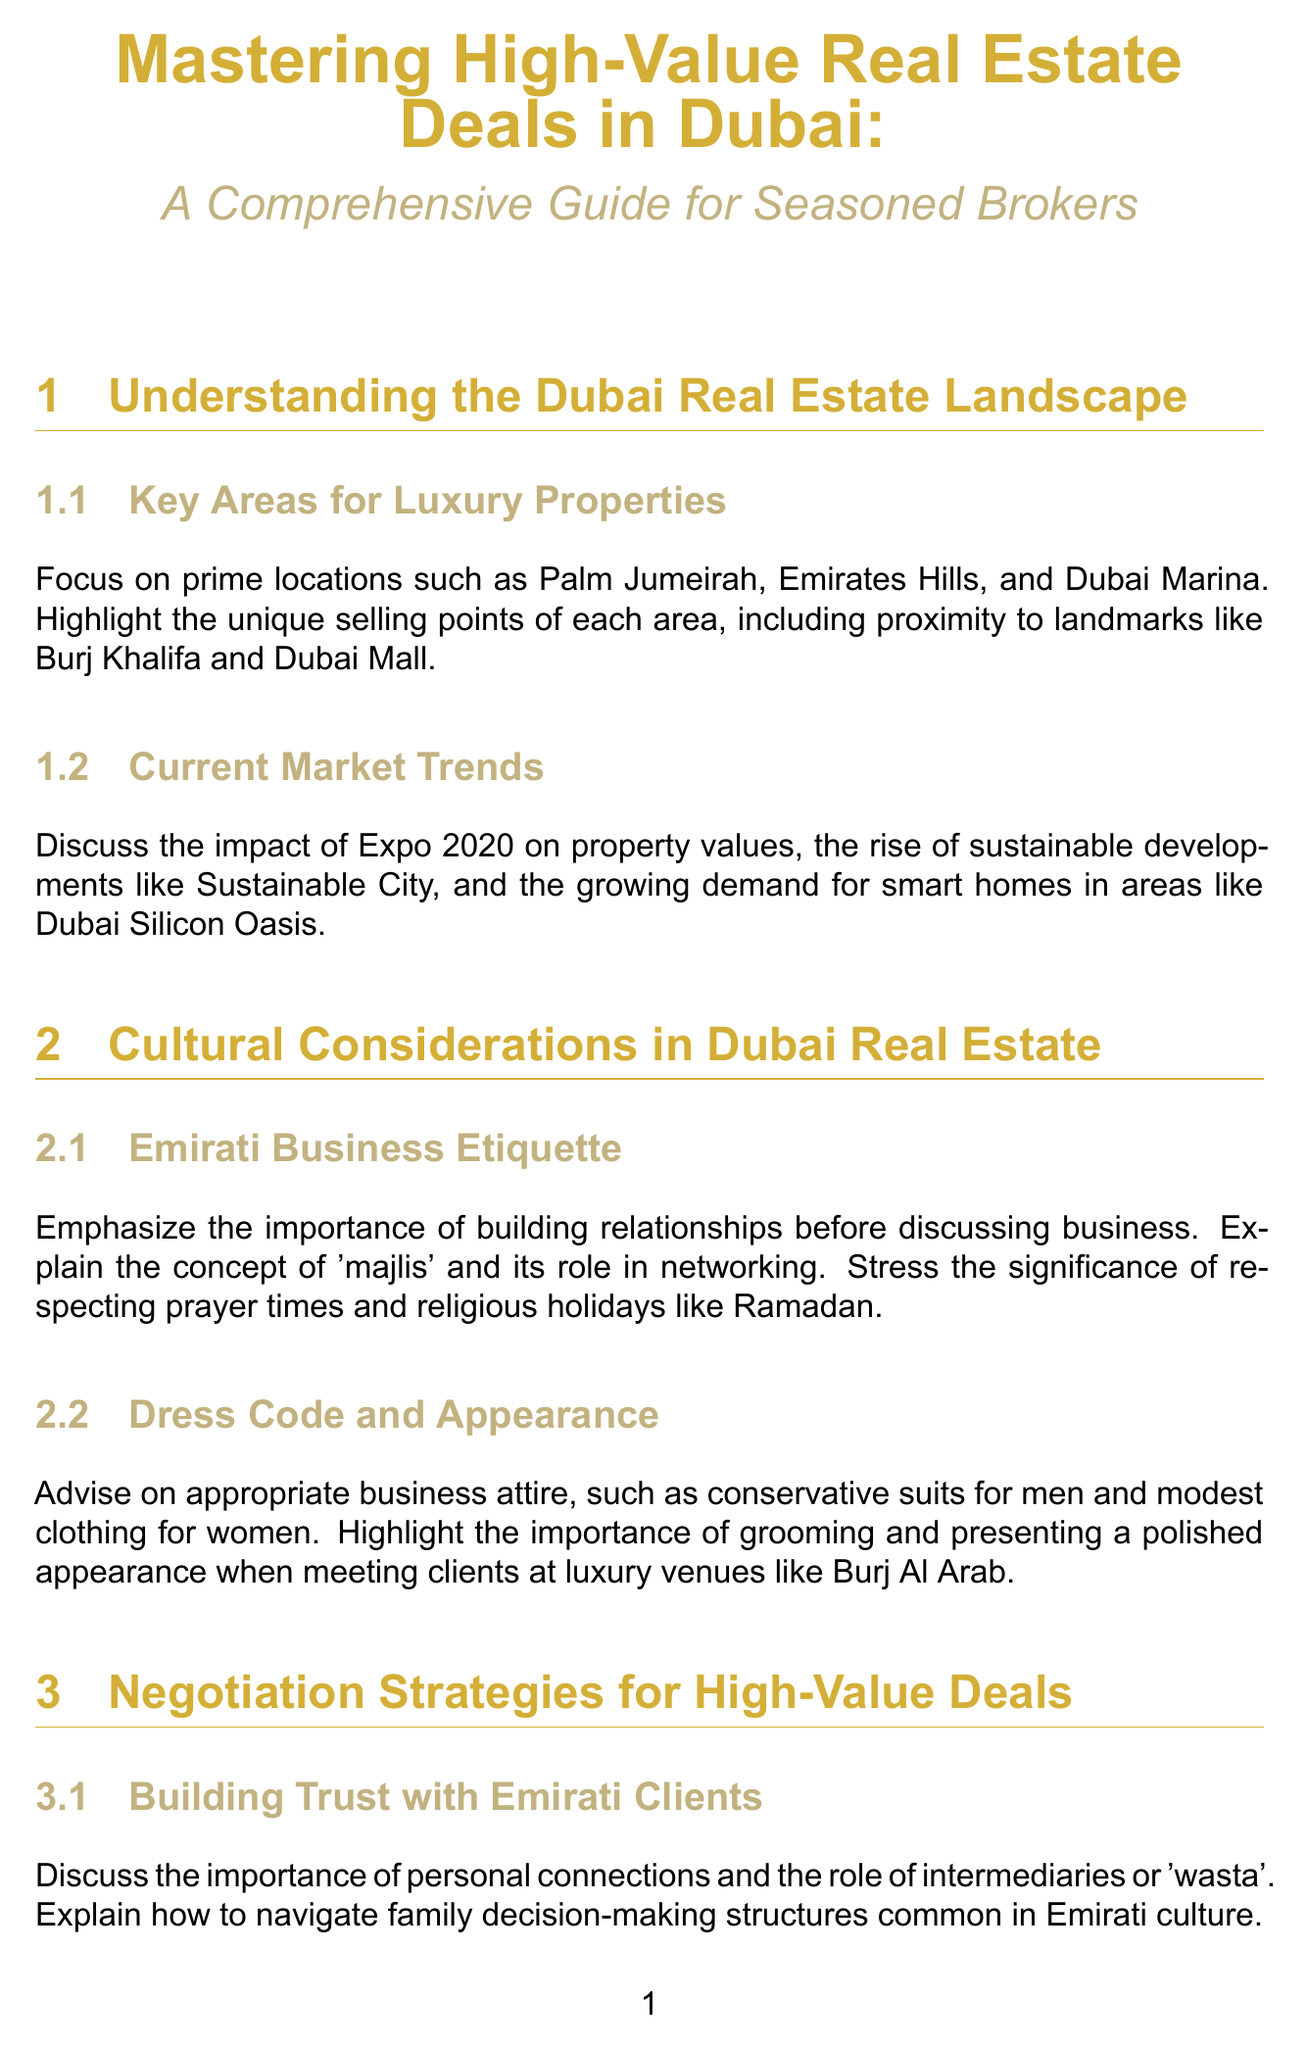What are the key areas for luxury properties in Dubai? The key areas for luxury properties highlighted in the document include Palm Jumeirah, Emirates Hills, and Dubai Marina.
Answer: Palm Jumeirah, Emirates Hills, Dubai Marina What does the concept of 'majlis' refer to? The document explains 'majlis' as a concept emphasizing the importance of building relationships before discussing business in Emirati culture.
Answer: A gathering place What financing principles are explained in the document? The document outlines Islamic financing principles and their application in real estate as part of financing options for high-net-worth clients.
Answer: Islamic financing principles Which two local banks are mentioned for tailored mortgage solutions? The document mentions partnerships with Emirates NBD and Mashreq for mortgage solutions for luxury properties.
Answer: Emirates NBD, Mashreq What is one negotiation technique emphasized for Emirati clients? The document discusses the importance of personal connections and the role of intermediaries or 'wasta' in building trust with Emirati clients.
Answer: Personal connections What type of property marketing is suggested for creating exclusivity? The document suggests strategies for marketing limited edition properties, such as penthouses in the Burj Khalifa or private islands in The World development.
Answer: Limited edition properties What should be avoided in gift-giving etiquette according to the document? The document advises avoiding alcohol in gift-giving etiquette while adhering to halal standards.
Answer: Alcohol What is a significant timing consideration mentioned for conducting business? The document stresses the significance of respecting prayer times and religious holidays like Ramadan when discussing business.
Answer: Prayer times, Ramadan 